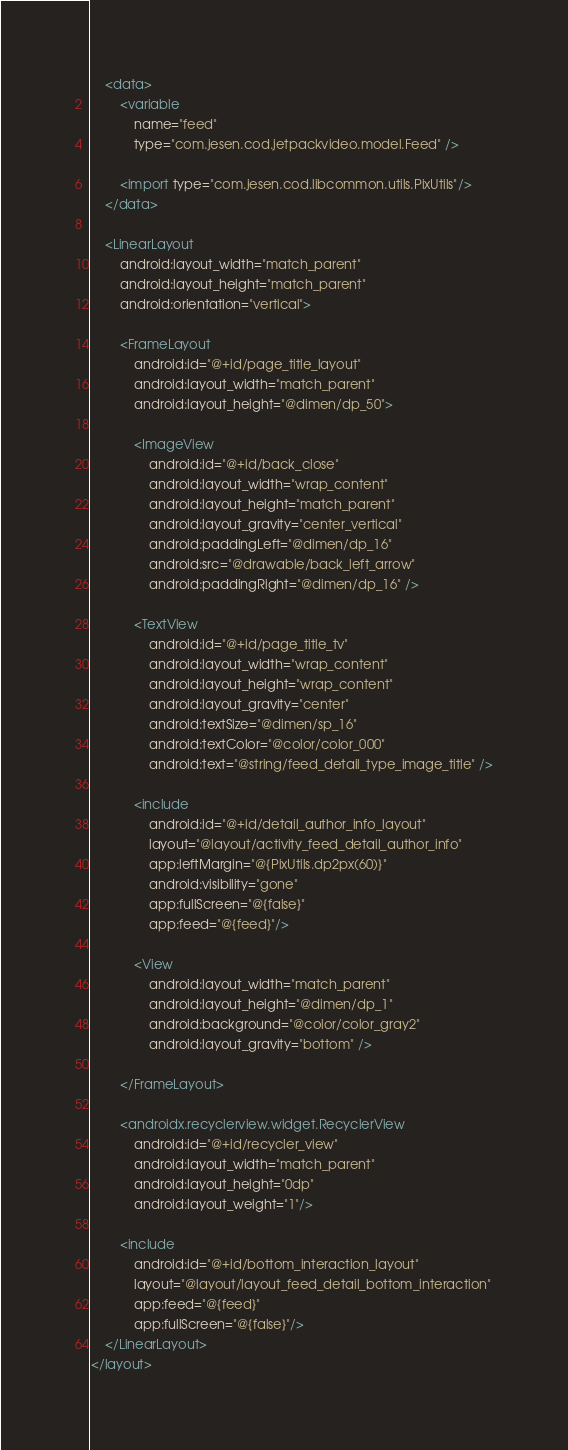<code> <loc_0><loc_0><loc_500><loc_500><_XML_>
    <data>
        <variable
            name="feed"
            type="com.jesen.cod.jetpackvideo.model.Feed" />

        <import type="com.jesen.cod.libcommon.utils.PixUtils"/>
    </data>

    <LinearLayout
        android:layout_width="match_parent"
        android:layout_height="match_parent"
        android:orientation="vertical">

        <FrameLayout
            android:id="@+id/page_title_layout"
            android:layout_width="match_parent"
            android:layout_height="@dimen/dp_50">

            <ImageView
                android:id="@+id/back_close"
                android:layout_width="wrap_content"
                android:layout_height="match_parent"
                android:layout_gravity="center_vertical"
                android:paddingLeft="@dimen/dp_16"
                android:src="@drawable/back_left_arrow"
                android:paddingRight="@dimen/dp_16" />

            <TextView
                android:id="@+id/page_title_tv"
                android:layout_width="wrap_content"
                android:layout_height="wrap_content"
                android:layout_gravity="center"
                android:textSize="@dimen/sp_16"
                android:textColor="@color/color_000"
                android:text="@string/feed_detail_type_image_title" />

            <include
                android:id="@+id/detail_author_info_layout"
                layout="@layout/activity_feed_detail_author_info"
                app:leftMargin="@{PixUtils.dp2px(60)}"
                android:visibility="gone"
                app:fullScreen="@{false}"
                app:feed="@{feed}"/>

            <View
                android:layout_width="match_parent"
                android:layout_height="@dimen/dp_1"
                android:background="@color/color_gray2"
                android:layout_gravity="bottom" />

        </FrameLayout>

        <androidx.recyclerview.widget.RecyclerView
            android:id="@+id/recycler_view"
            android:layout_width="match_parent"
            android:layout_height="0dp"
            android:layout_weight="1"/>

        <include
            android:id="@+id/bottom_interaction_layout"
            layout="@layout/layout_feed_detail_bottom_interaction"
            app:feed="@{feed}"
            app:fullScreen="@{false}"/>
    </LinearLayout>
</layout></code> 